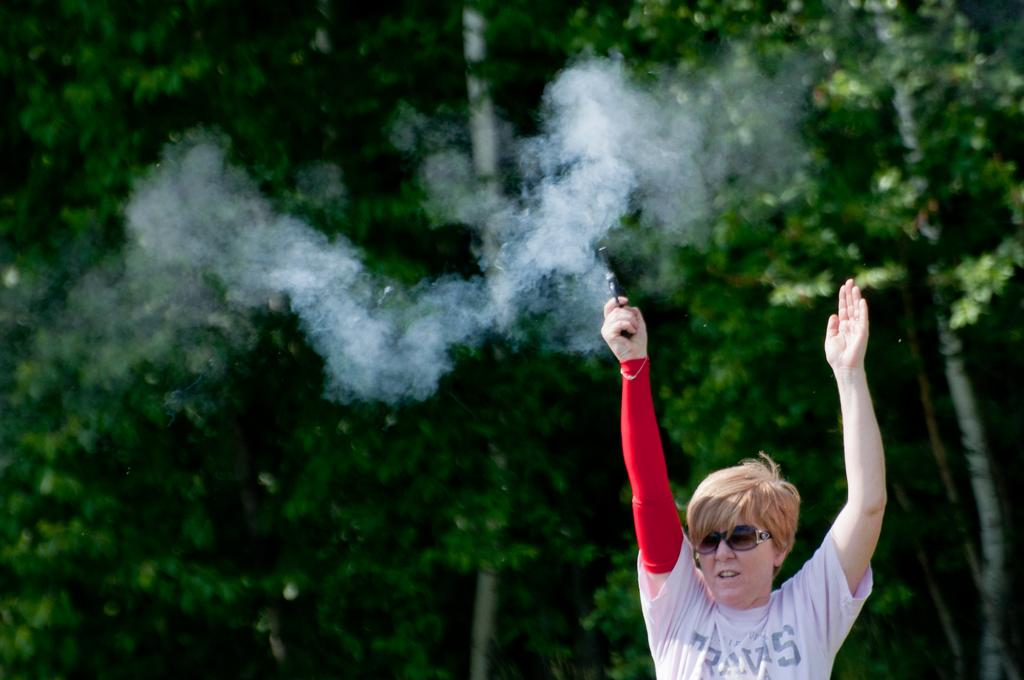What is the person on the right side of the image doing? The person is standing on the right side of the image and holding a gun. What can be seen in the background of the image? There are trees in the background of the image. What type of bait is the person using to catch fish in the image? There is no indication of fishing or bait in the image; the person is holding a gun. What kind of joke is the person telling in the image? There is no indication of a joke or any conversation in the image; the person is holding a gun. 